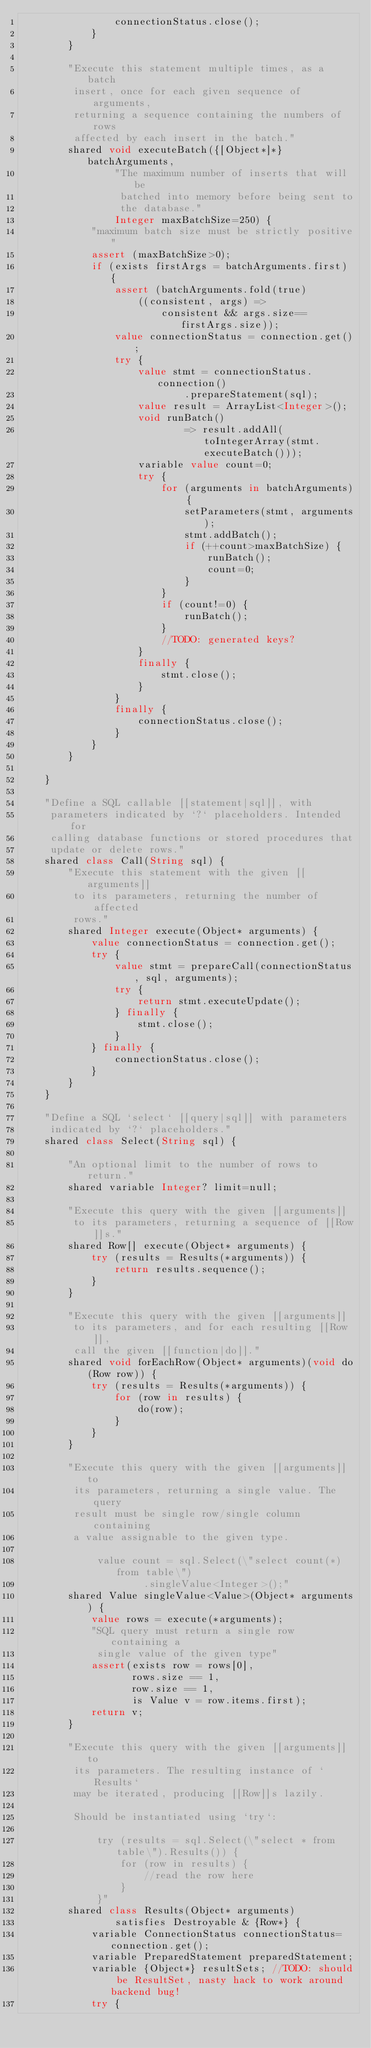<code> <loc_0><loc_0><loc_500><loc_500><_Ceylon_>                connectionStatus.close();
            }
        }
        
        "Execute this statement multiple times, as a batch
         insert, once for each given sequence of arguments, 
         returning a sequence containing the numbers of rows 
         affected by each insert in the batch."
        shared void executeBatch({[Object*]*} batchArguments,
                "The maximum number of inserts that will be
                 batched into memory before being sent to
                 the database."
                Integer maxBatchSize=250) {
            "maximum batch size must be strictly positive"
            assert (maxBatchSize>0);
            if (exists firstArgs = batchArguments.first) {
                assert (batchArguments.fold(true) 
                    ((consistent, args) => 
                        consistent && args.size==firstArgs.size));
                value connectionStatus = connection.get();
                try {
                    value stmt = connectionStatus.connection()
                            .prepareStatement(sql);
                    value result = ArrayList<Integer>();
                    void runBatch()
                            => result.addAll(toIntegerArray(stmt.executeBatch()));
                    variable value count=0;
                    try {                    
                        for (arguments in batchArguments) {
                            setParameters(stmt, arguments);
                            stmt.addBatch();
                            if (++count>maxBatchSize) {
                                runBatch();
                                count=0;
                            }
                        }
                        if (count!=0) {
                            runBatch();
                        }
                        //TODO: generated keys?
                    }
                    finally {
                        stmt.close();
                    }
                }
                finally {
                    connectionStatus.close();
                }
            }
        }
        
    }
    
    "Define a SQL callable [[statement|sql]], with 
     parameters indicated by `?` placeholders. Intended for 
     calling database functions or stored procedures that 
     update or delete rows."
    shared class Call(String sql) {
        "Execute this statement with the given [[arguments]] 
         to its parameters, returning the number of affected 
         rows."
        shared Integer execute(Object* arguments) {
            value connectionStatus = connection.get();
            try {
                value stmt = prepareCall(connectionStatus, sql, arguments);
                try {
                    return stmt.executeUpdate();
                } finally {
                    stmt.close();
                }
            } finally {
                connectionStatus.close();
            }
        }
    }
    
    "Define a SQL `select` [[query|sql]] with parameters 
     indicated by `?` placeholders."
    shared class Select(String sql) {
        
        "An optional limit to the number of rows to return."
        shared variable Integer? limit=null;
        
        "Execute this query with the given [[arguments]] 
         to its parameters, returning a sequence of [[Row]]s."
        shared Row[] execute(Object* arguments) {
            try (results = Results(*arguments)) {
                return results.sequence();
            }
        }
        
        "Execute this query with the given [[arguments]] 
         to its parameters, and for each resulting [[Row]],
         call the given [[function|do]]."
        shared void forEachRow(Object* arguments)(void do(Row row)) {
            try (results = Results(*arguments)) {
                for (row in results) {
                    do(row);
                }
            }
        }
        
        "Execute this query with the given [[arguments]] to 
         its parameters, returning a single value. The query 
         result must be single row/single column containing
         a value assignable to the given type.
         
             value count = sql.Select(\"select count(*) from table\")
                     .singleValue<Integer>();"
        shared Value singleValue<Value>(Object* arguments) {
            value rows = execute(*arguments);
            "SQL query must return a single row containing a 
             single value of the given type"
            assert(exists row = rows[0], 
                   rows.size == 1, 
                   row.size == 1, 
                   is Value v = row.items.first);
            return v;
        }        
        
        "Execute this query with the given [[arguments]] to 
         its parameters. The resulting instance of `Results` 
         may be iterated, producing [[Row]]s lazily.
         
         Should be instantiated using `try`:
         
             try (results = sql.Select(\"select * from table\").Results()) {
                 for (row in results) {
                     //read the row here
                 }
             }"
        shared class Results(Object* arguments) 
                satisfies Destroyable & {Row*} {
            variable ConnectionStatus connectionStatus=connection.get();
            variable PreparedStatement preparedStatement;
            variable {Object*} resultSets; //TODO: should be ResultSet, nasty hack to work around backend bug!
            try {</code> 